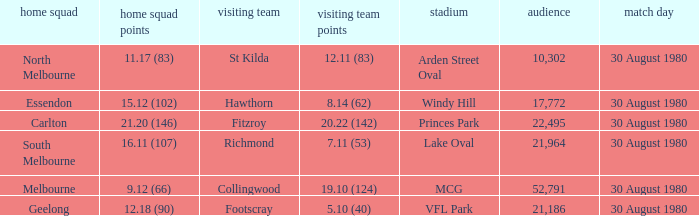What was the crowd when the away team is footscray? 21186.0. 